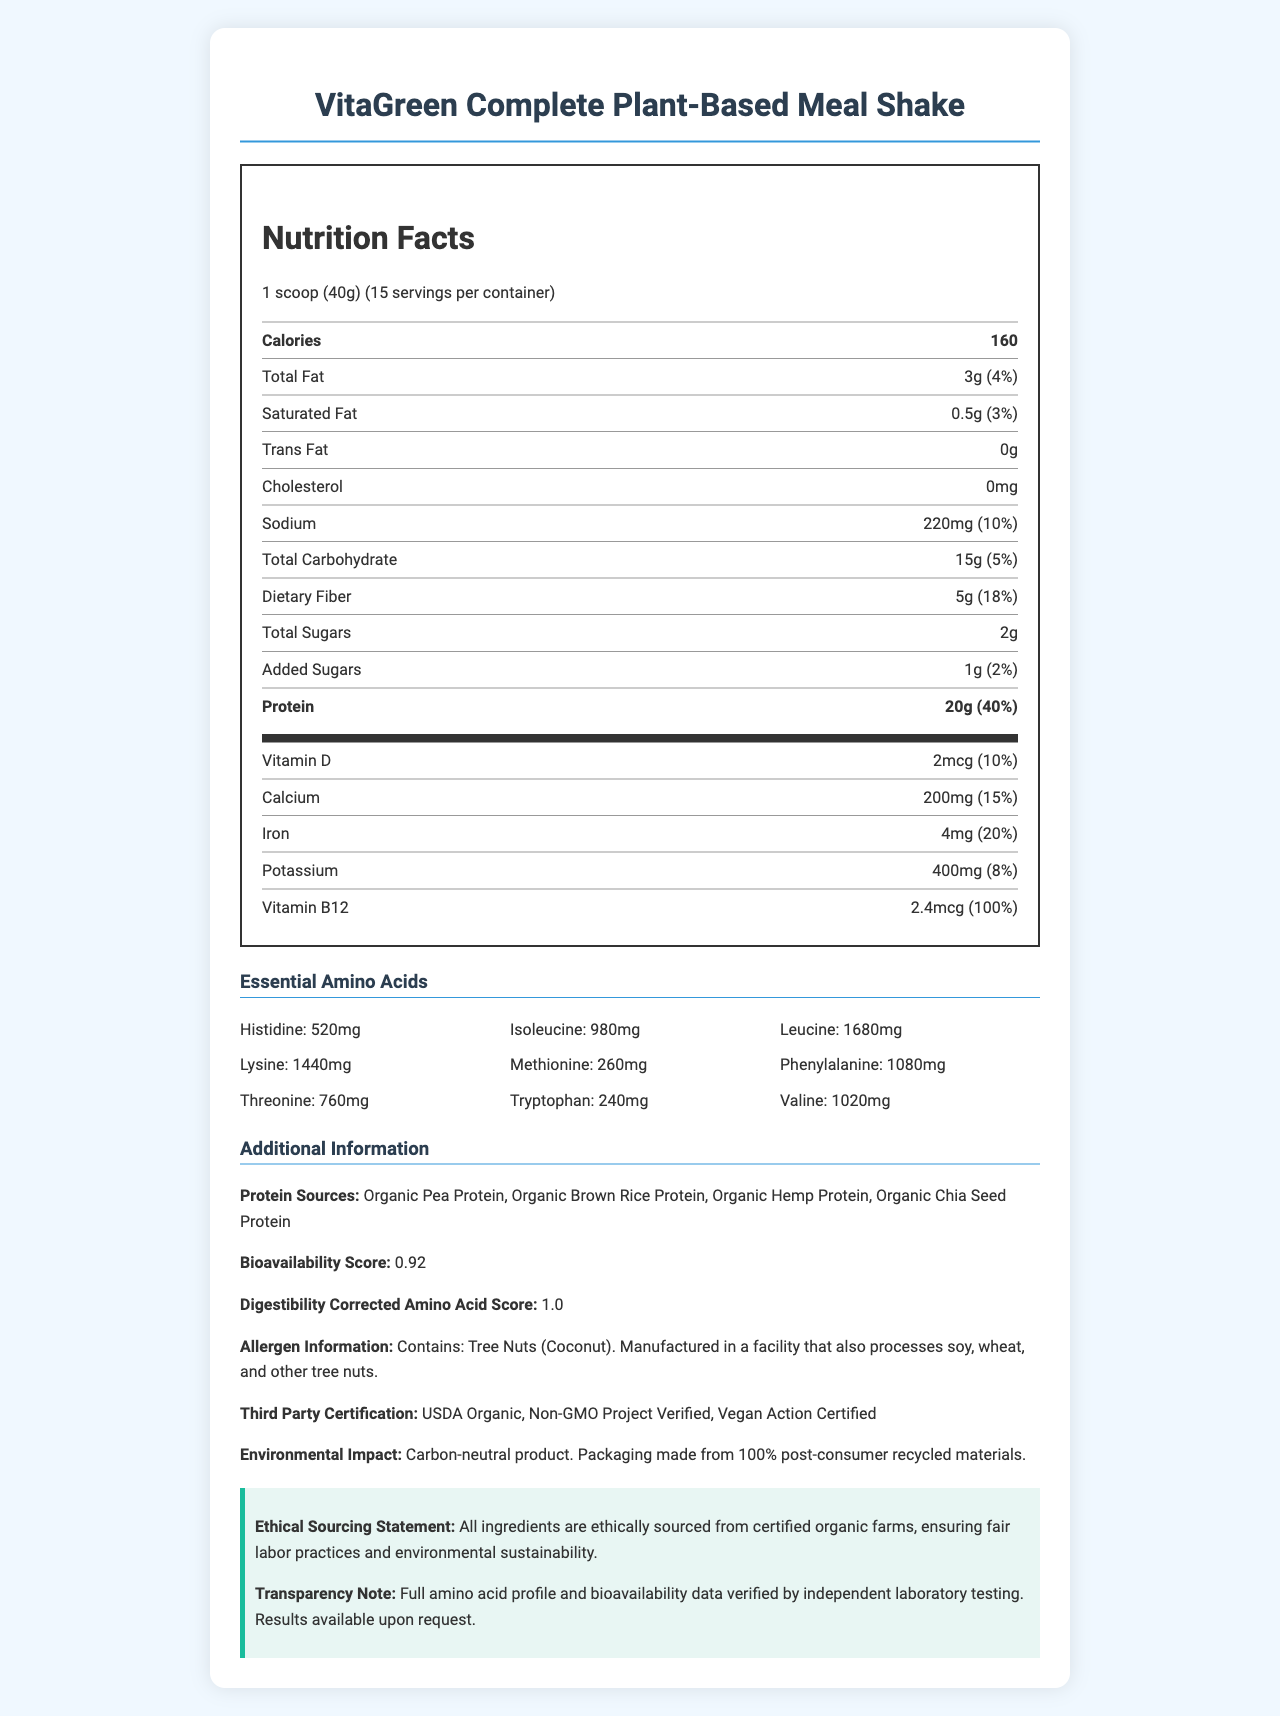what is the serving size? The serving size is indicated at the top of the Nutrition Facts label.
Answer: 1 scoop (40g) how many servings per container are there? The document mentions that there are 15 servings per container.
Answer: 15 what is the total fat content per serving? The total fat is listed as 3g per serving in the nutrition facts section.
Answer: 3g how much protein is in one serving? The protein content is stated to be 20g per serving.
Answer: 20g name three protein sources used in this product The protein sources listed include Organic Pea Protein, Organic Brown Rice Protein, Organic Hemp Protein, and Organic Chia Seed Protein.
Answer: Organic Pea Protein, Organic Brown Rice Protein, Organic Hemp Protein how many milligrams of potassium are in one serving? The potassium content per serving is listed as 400mg.
Answer: 400mg what is the bioavailability score of this product? The bioavailability score is indicated as 0.92 in the additional information section.
Answer: 0.92 what is the daily value percentage of Vitamin B12 per serving? The daily value percentage for Vitamin B12 is provided as 100%.
Answer: 100% which essential amino acid has the lowest amount in one serving? The essential amino acids section shows that Tryptophan has the lowest amount at 240mg.
Answer: Tryptophan what is the environmental impact of the product's packaging? The document states that the packaging is made from 100% post-consumer recycled materials.
Answer: Packaging made from 100% post-consumer recycled materials what percentage of daily value does dietary fiber provide? The dietary fiber provides 18% of the daily value.
Answer: 18% is this product vegan certified? The third-party certification indicates that the product is Vegan Action Certified.
Answer: Yes how many grams of added sugars are in one serving? The added sugars content per serving is listed as 1g.
Answer: 1g which certification ensures the product is non-GMO? The third-party certification section lists Non-GMO Project Verified.
Answer: Non-GMO Project Verified the product includes which allergens? A. Dairy B. Soy C. Tree Nuts D. Gluten The allergen information specifies that the product contains Tree Nuts (Coconut).
Answer: C what is the corrected amino acid score for digestibility? A. 0.75 B. 0.92 C. 1.0 D. 1.2 The digestibility corrected amino acid score is listed as 1.0.
Answer: C how many amino acids are detailed in the essential amino acids section? A. 6 B. 7 C. 8 D. 9 There are 9 essential amino acids listed: Histidine, Isoleucine, Leucine, Lysine, Methionine, Phenylalanine, Threonine, Tryptophan, and Valine.
Answer: D was the amino acid profile verified by a third-party laboratory? The transparency note indicates that the amino acid profile was verified by independent laboratory testing.
Answer: Yes describe the main idea of this document This document serves as a detailed Nutrition Facts label for a plant-based meal replacement shake, giving specific information about its nutritional content and additional details on certifications and ethical sourcing.
Answer: The document provides the nutritional information for VitaGreen Complete Plant-Based Meal Shake, outlining the serving size, calories, total fats, protein, essential amino acids, protein sources, bioavailability score, allergen information, and sustainability certifications. does this product contain any gluten? The allergen information provided does not specify whether the product contains gluten, only that it is manufactured in a facility that processes wheat.
Answer: Not enough information 